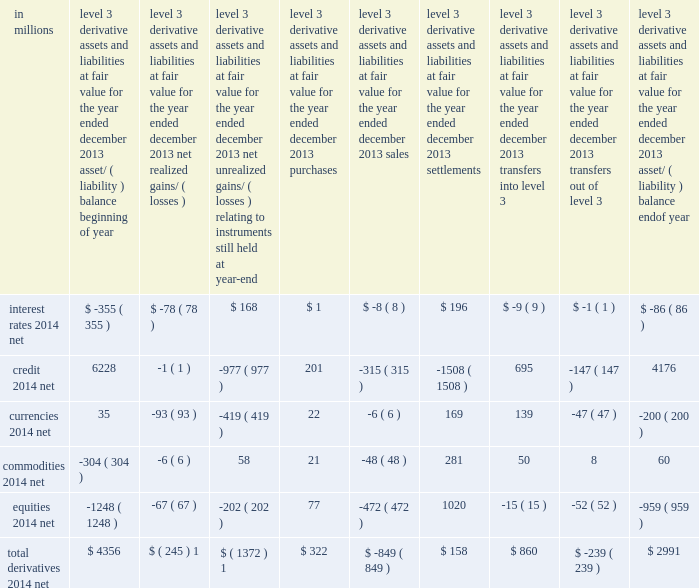Notes to consolidated financial statements level 3 rollforward if a derivative was transferred to level 3 during a reporting period , its entire gain or loss for the period is included in level 3 .
Transfers between levels are reported at the beginning of the reporting period in which they occur .
In the tables below , negative amounts for transfers into level 3 and positive amounts for transfers out of level 3 represent net transfers of derivative liabilities .
Gains and losses on level 3 derivatives should be considered in the context of the following : 2030 a derivative with level 1 and/or level 2 inputs is classified in level 3 in its entirety if it has at least one significant level 3 input .
2030 if there is one significant level 3 input , the entire gain or loss from adjusting only observable inputs ( i.e. , level 1 and level 2 inputs ) is classified as level 3 .
2030 gains or losses that have been reported in level 3 resulting from changes in level 1 or level 2 inputs are frequently offset by gains or losses attributable to level 1 or level 2 derivatives and/or level 1 , level 2 and level 3 cash instruments .
As a result , gains/ ( losses ) included in the level 3 rollforward below do not necessarily represent the overall impact on the firm 2019s results of operations , liquidity or capital resources .
The tables below present changes in fair value for all derivatives categorized as level 3 as of the end of the year. .
The aggregate amounts include losses of approximately $ 1.29 billion and $ 324 million reported in 201cmarket making 201d and 201cother principal transactions , 201d respectively .
The net unrealized loss on level 3 derivatives of $ 1.37 billion for 2013 principally resulted from changes in level 2 inputs and was primarily attributable to losses on certain credit derivatives , principally due to the impact of tighter credit spreads , and losses on certain currency derivatives , primarily due to changes in foreign exchange rates .
Transfers into level 3 derivatives during 2013 primarily reflected transfers of credit derivative assets from level 2 , principally due to reduced transparency of upfront credit points and correlation inputs used to value these derivatives .
Transfers out of level 3 derivatives during 2013 primarily reflected transfers of certain credit derivatives to level 2 , principally due to unobservable credit spread and correlation inputs no longer being significant to the valuation of these derivatives and unobservable inputs not being significant to the net risk of certain portfolios .
Goldman sachs 2013 annual report 143 .
What was the difference in millions in the aggregate amount of losses reported in 201cmarket making 201d and 201cother principal transactions 201d respectively? 
Computations: ((1.29 * 1000) - 324)
Answer: 966.0. 